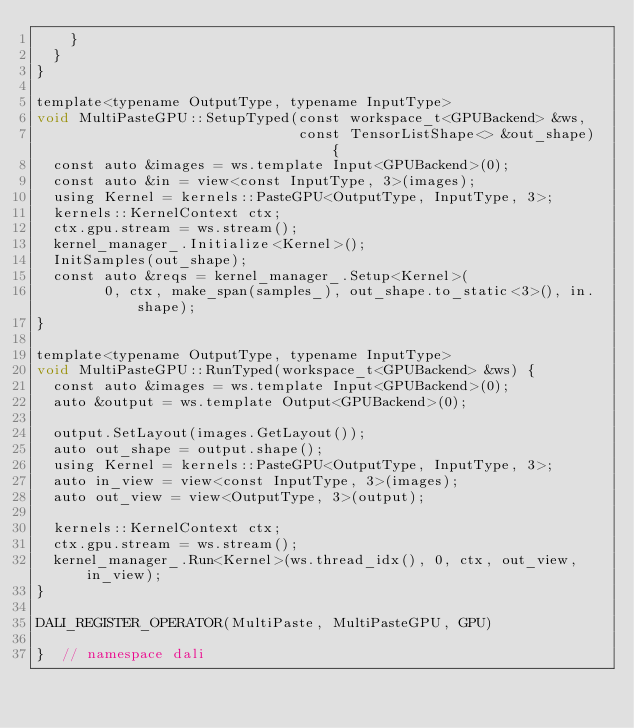<code> <loc_0><loc_0><loc_500><loc_500><_Cuda_>    }
  }
}

template<typename OutputType, typename InputType>
void MultiPasteGPU::SetupTyped(const workspace_t<GPUBackend> &ws,
                               const TensorListShape<> &out_shape) {
  const auto &images = ws.template Input<GPUBackend>(0);
  const auto &in = view<const InputType, 3>(images);
  using Kernel = kernels::PasteGPU<OutputType, InputType, 3>;
  kernels::KernelContext ctx;
  ctx.gpu.stream = ws.stream();
  kernel_manager_.Initialize<Kernel>();
  InitSamples(out_shape);
  const auto &reqs = kernel_manager_.Setup<Kernel>(
        0, ctx, make_span(samples_), out_shape.to_static<3>(), in.shape);
}

template<typename OutputType, typename InputType>
void MultiPasteGPU::RunTyped(workspace_t<GPUBackend> &ws) {
  const auto &images = ws.template Input<GPUBackend>(0);
  auto &output = ws.template Output<GPUBackend>(0);

  output.SetLayout(images.GetLayout());
  auto out_shape = output.shape();
  using Kernel = kernels::PasteGPU<OutputType, InputType, 3>;
  auto in_view = view<const InputType, 3>(images);
  auto out_view = view<OutputType, 3>(output);

  kernels::KernelContext ctx;
  ctx.gpu.stream = ws.stream();
  kernel_manager_.Run<Kernel>(ws.thread_idx(), 0, ctx, out_view, in_view);
}

DALI_REGISTER_OPERATOR(MultiPaste, MultiPasteGPU, GPU)

}  // namespace dali
</code> 